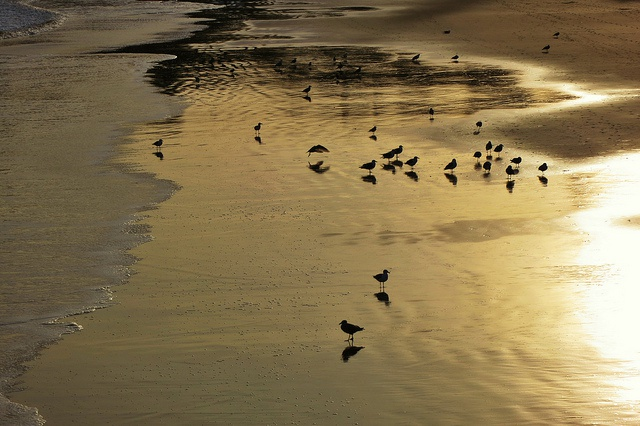Describe the objects in this image and their specific colors. I can see bird in black, gray, and tan tones, bird in black, olive, and darkgreen tones, bird in black, tan, maroon, and gray tones, bird in black, olive, tan, and maroon tones, and bird in black, olive, and gray tones in this image. 